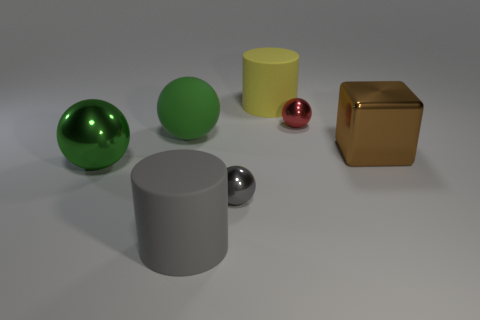Subtract all small red balls. How many balls are left? 3 Subtract all cyan cubes. How many green spheres are left? 2 Add 2 balls. How many objects exist? 9 Subtract all balls. How many objects are left? 3 Subtract 3 balls. How many balls are left? 1 Add 7 rubber objects. How many rubber objects exist? 10 Subtract all gray cylinders. How many cylinders are left? 1 Subtract 0 blue cubes. How many objects are left? 7 Subtract all yellow cubes. Subtract all green balls. How many cubes are left? 1 Subtract all large matte balls. Subtract all metallic things. How many objects are left? 2 